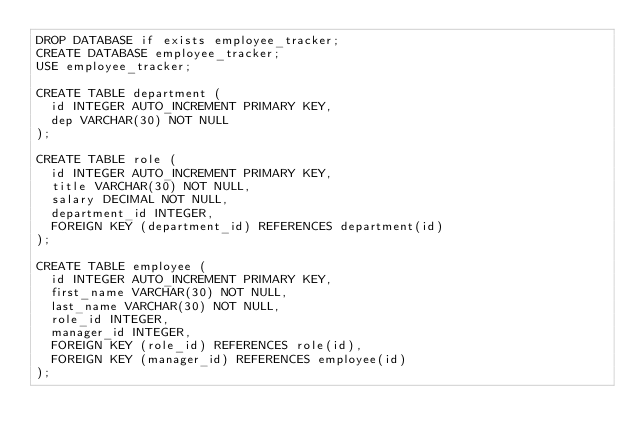Convert code to text. <code><loc_0><loc_0><loc_500><loc_500><_SQL_>DROP DATABASE if exists employee_tracker;
CREATE DATABASE employee_tracker;
USE employee_tracker;

CREATE TABLE department (
  id INTEGER AUTO_INCREMENT PRIMARY KEY,
  dep VARCHAR(30) NOT NULL  
);

CREATE TABLE role (
  id INTEGER AUTO_INCREMENT PRIMARY KEY,
  title VARCHAR(30) NOT NULL,
  salary DECIMAL NOT NULL,
  department_id INTEGER,
  FOREIGN KEY (department_id) REFERENCES department(id)
);

CREATE TABLE employee (
  id INTEGER AUTO_INCREMENT PRIMARY KEY,
  first_name VARCHAR(30) NOT NULL,  
  last_name VARCHAR(30) NOT NULL,  
  role_id INTEGER,
  manager_id INTEGER,
  FOREIGN KEY (role_id) REFERENCES role(id),
  FOREIGN KEY (manager_id) REFERENCES employee(id)
);</code> 